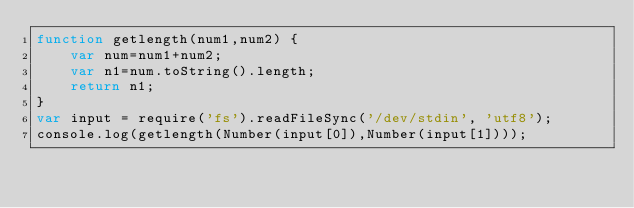<code> <loc_0><loc_0><loc_500><loc_500><_JavaScript_>function getlength(num1,num2) {
    var num=num1+num2;
    var n1=num.toString().length;
    return n1;
}
var input = require('fs').readFileSync('/dev/stdin', 'utf8');
console.log(getlength(Number(input[0]),Number(input[1])));</code> 